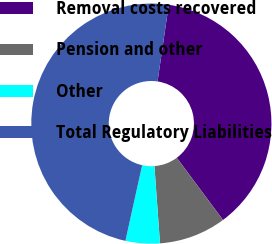<chart> <loc_0><loc_0><loc_500><loc_500><pie_chart><fcel>Removal costs recovered<fcel>Pension and other<fcel>Other<fcel>Total Regulatory Liabilities<nl><fcel>37.51%<fcel>9.03%<fcel>4.61%<fcel>48.85%<nl></chart> 